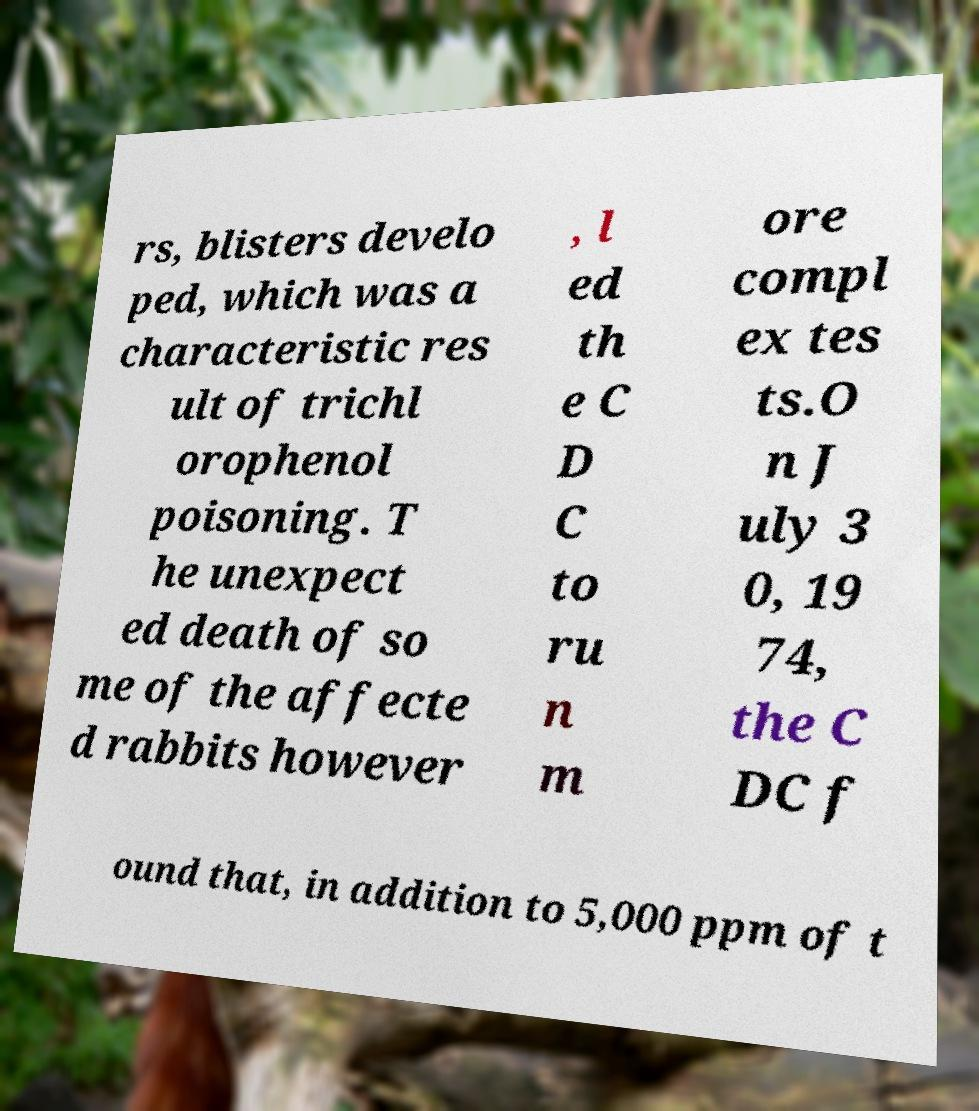For documentation purposes, I need the text within this image transcribed. Could you provide that? rs, blisters develo ped, which was a characteristic res ult of trichl orophenol poisoning. T he unexpect ed death of so me of the affecte d rabbits however , l ed th e C D C to ru n m ore compl ex tes ts.O n J uly 3 0, 19 74, the C DC f ound that, in addition to 5,000 ppm of t 